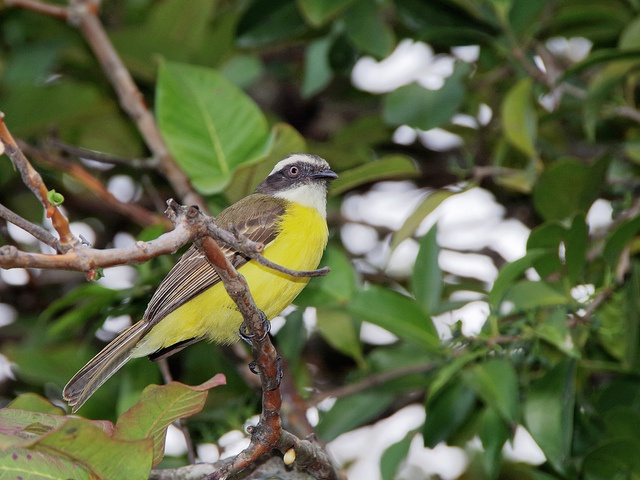Describe the objects in this image and their specific colors. I can see a bird in olive, gray, tan, darkgray, and khaki tones in this image. 